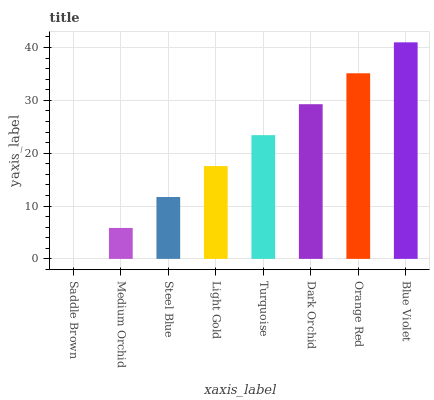Is Saddle Brown the minimum?
Answer yes or no. Yes. Is Blue Violet the maximum?
Answer yes or no. Yes. Is Medium Orchid the minimum?
Answer yes or no. No. Is Medium Orchid the maximum?
Answer yes or no. No. Is Medium Orchid greater than Saddle Brown?
Answer yes or no. Yes. Is Saddle Brown less than Medium Orchid?
Answer yes or no. Yes. Is Saddle Brown greater than Medium Orchid?
Answer yes or no. No. Is Medium Orchid less than Saddle Brown?
Answer yes or no. No. Is Turquoise the high median?
Answer yes or no. Yes. Is Light Gold the low median?
Answer yes or no. Yes. Is Light Gold the high median?
Answer yes or no. No. Is Blue Violet the low median?
Answer yes or no. No. 